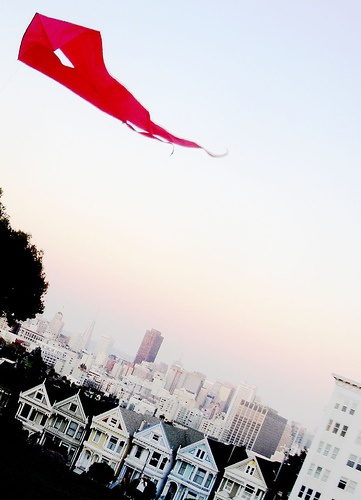Describe the objects in this image and their specific colors. I can see a kite in lavender and brown tones in this image. 